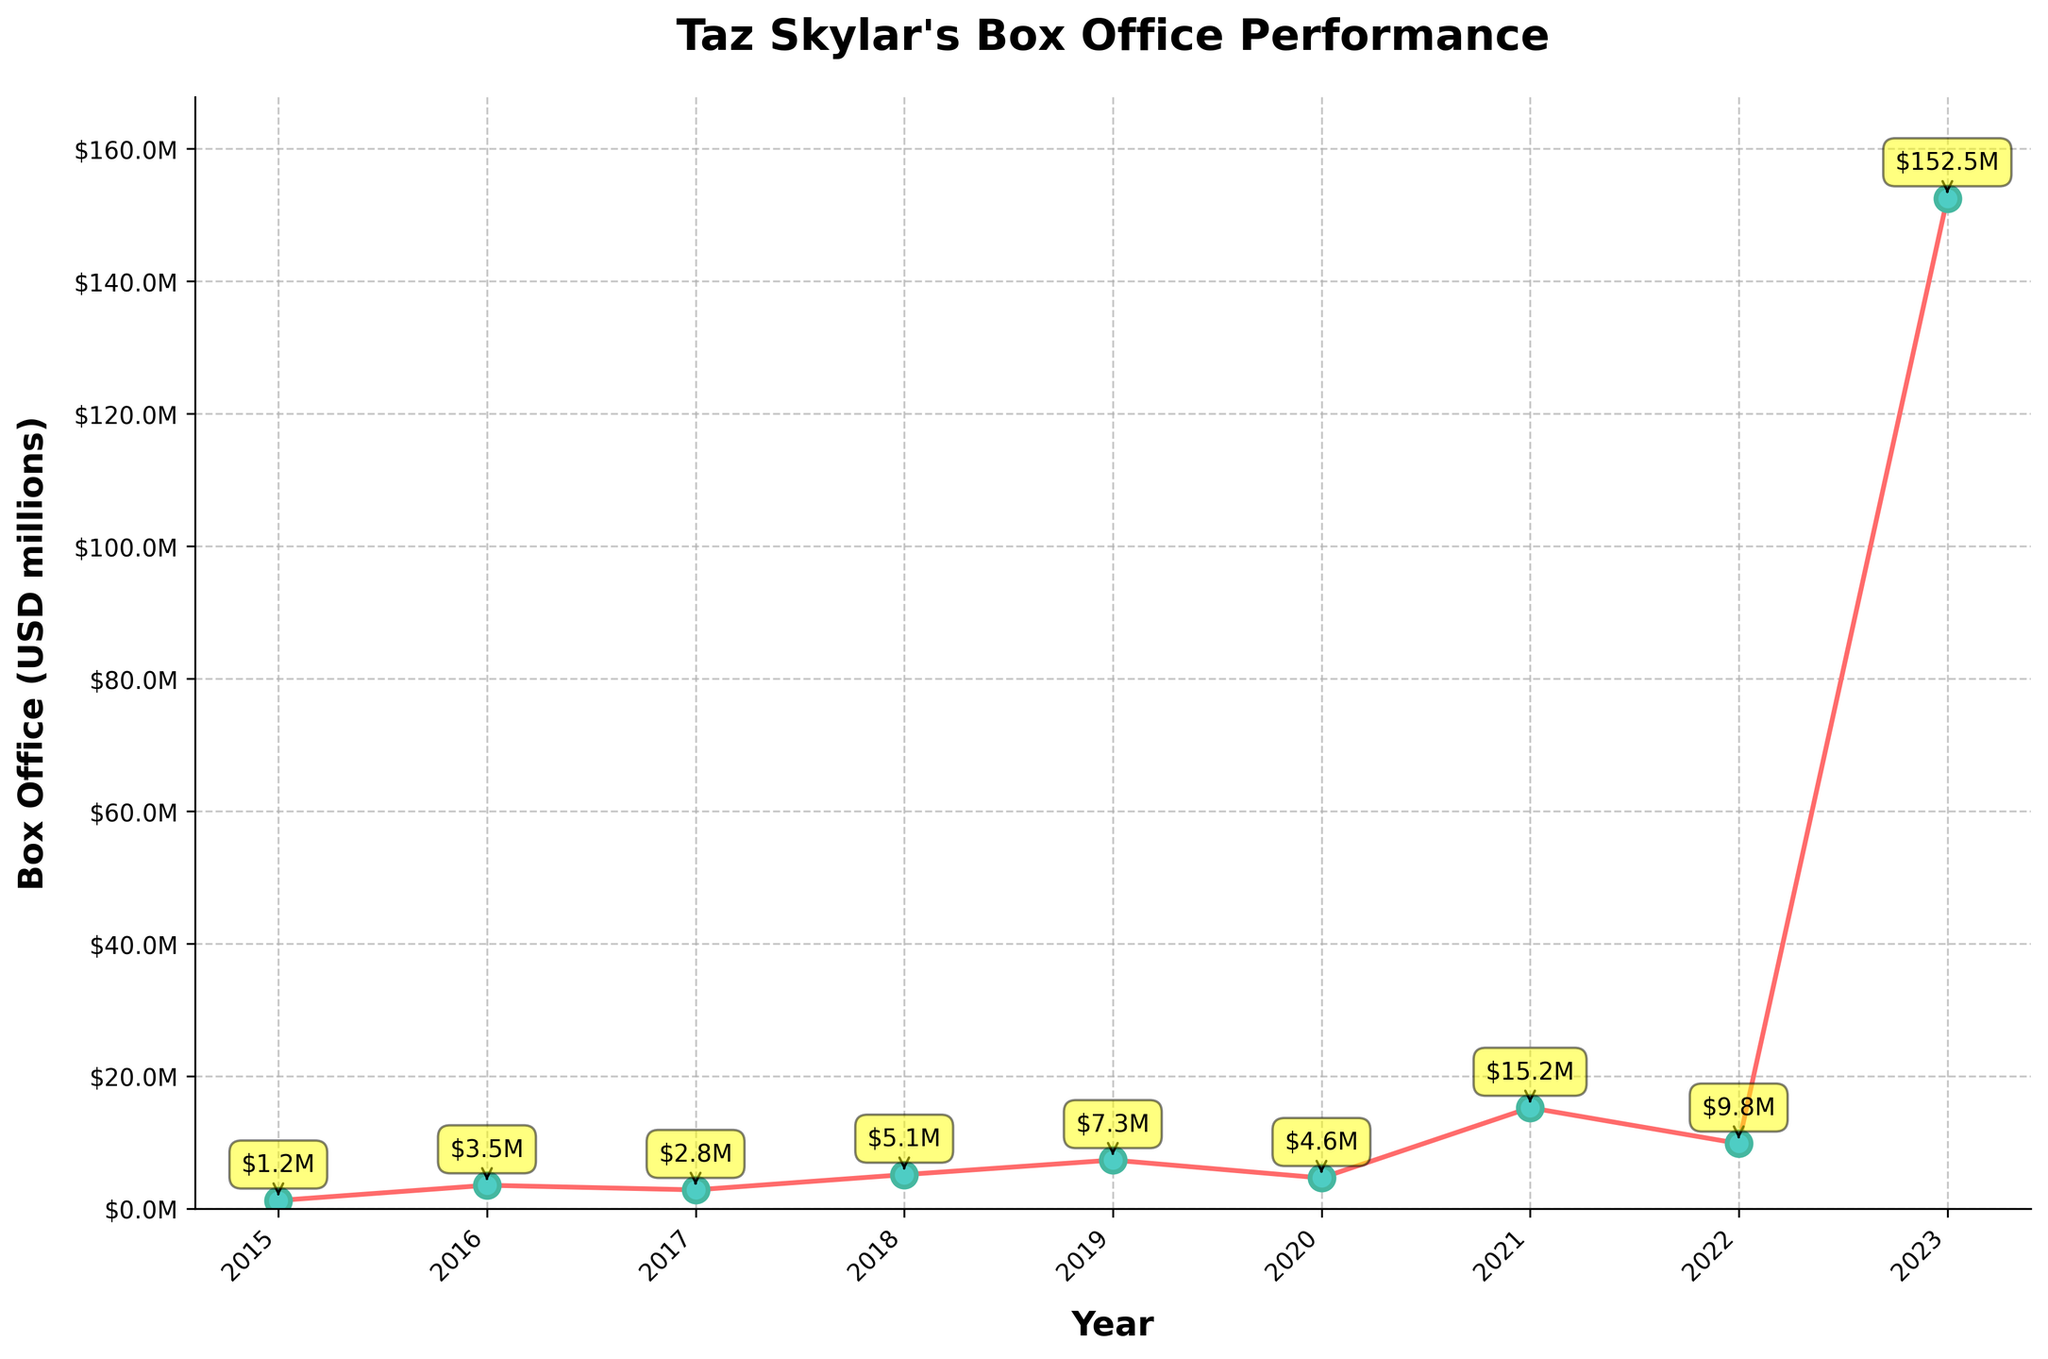Which film had the highest box office performance? The film with the highest box office performance can be identified by the peak point on the line chart. The highest peak corresponds to "The Hunger Games: The Ballad of Songbirds and Snakes" in 2023, with $152.5 million.
Answer: "The Hunger Games: The Ballad of Songbirds and Snakes" What is the overall trend in Taz Skylar's box office performance over the years? By looking at the trend line, we see an overall upward trajectory with some fluctuations. The performance starts relatively low in 2015, peaks at $152.5 million in 2023.
Answer: Upward trend with fluctuations How much did "Boiling Point" make at the box office in 2019? The data point on the line chart for 2019 shows "Boiling Point" with a box office performance of $7.3 million.
Answer: $7.3 million Compare the box office earnings of "The Kill Team" in 2018 and "Villain" in 2020. Which film performed better? The line chart shows that "The Kill Team" made $5.1 million in 2018, whereas "Villain" made $4.6 million in 2020. Therefore, "The Kill Team" performed better.
Answer: "The Kill Team" What is the combined earnings of all films released between 2015 and 2020? Summing the box office figures from 2015 to 2020: 1.2 + 3.5 + 2.8 + 5.1 + 7.3 + 4.6 = 24.5 million.
Answer: $24.5 million Which year had the lowest box office earnings, and how much was it? The lowest point on the line chart can be found in 2015 for the film "Hyena Road," which made $1.2 million.
Answer: 2015, $1.2 million How much did Taz Skylar's box office earnings improve from "Hyena Road" in 2015 to "One Piece" in 2021? Subtracting the earnings of "Hyena Road" ($1.2 million) from "One Piece" ($15.2 million): 15.2 - 1.2 = 14.
Answer: $14 million What do you observe about the box office performance in the year 2023 compared to the previous years? The box office earning in 2023 for "The Hunger Games: The Ballad of Songbirds and Snakes" is $152.5 million, which is significantly higher compared to all previous years. This indicates a massive surge.
Answer: Significant surge in 2023 If we excluded the highest earning film, what would be the average box office performance of the remaining films? Excluding "The Hunger Games: The Ballad of Songbirds and Snakes" ($152.5 million), the sum of the remaining films' earnings is: 1.2 + 3.5 + 2.8 + 5.1 + 7.3 + 4.6 + 15.2 + 9.8 = 49.5 million. The number of these films is 8, so the average is 49.5 / 8 = 6.19.
Answer: $6.19 million 